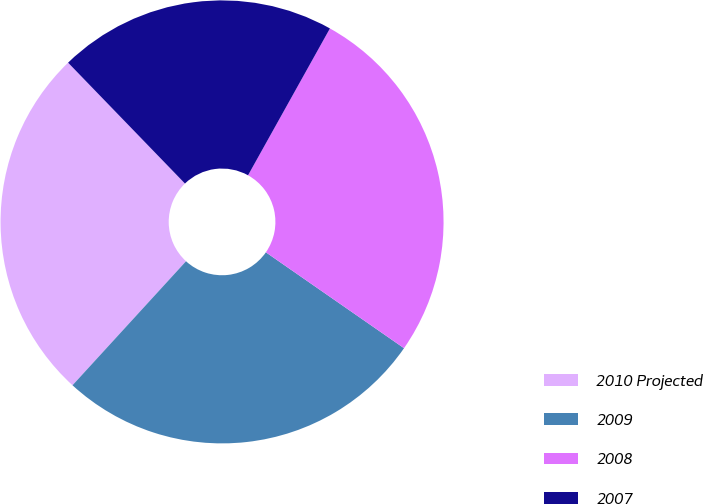Convert chart to OTSL. <chart><loc_0><loc_0><loc_500><loc_500><pie_chart><fcel>2010 Projected<fcel>2009<fcel>2008<fcel>2007<nl><fcel>25.97%<fcel>27.14%<fcel>26.56%<fcel>20.33%<nl></chart> 